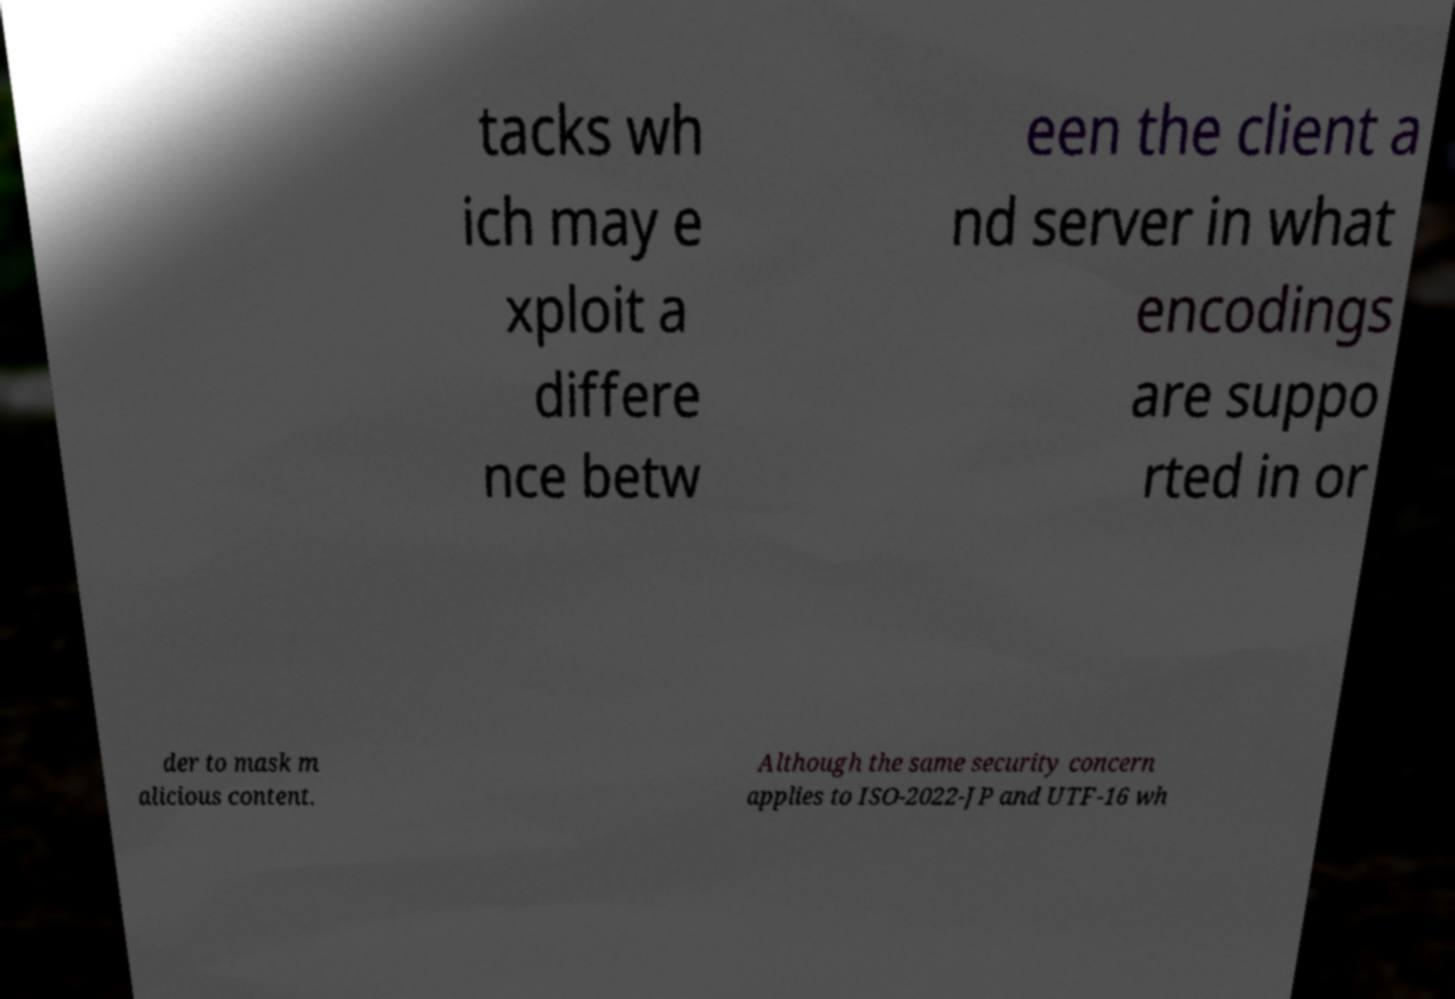Can you accurately transcribe the text from the provided image for me? tacks wh ich may e xploit a differe nce betw een the client a nd server in what encodings are suppo rted in or der to mask m alicious content. Although the same security concern applies to ISO-2022-JP and UTF-16 wh 